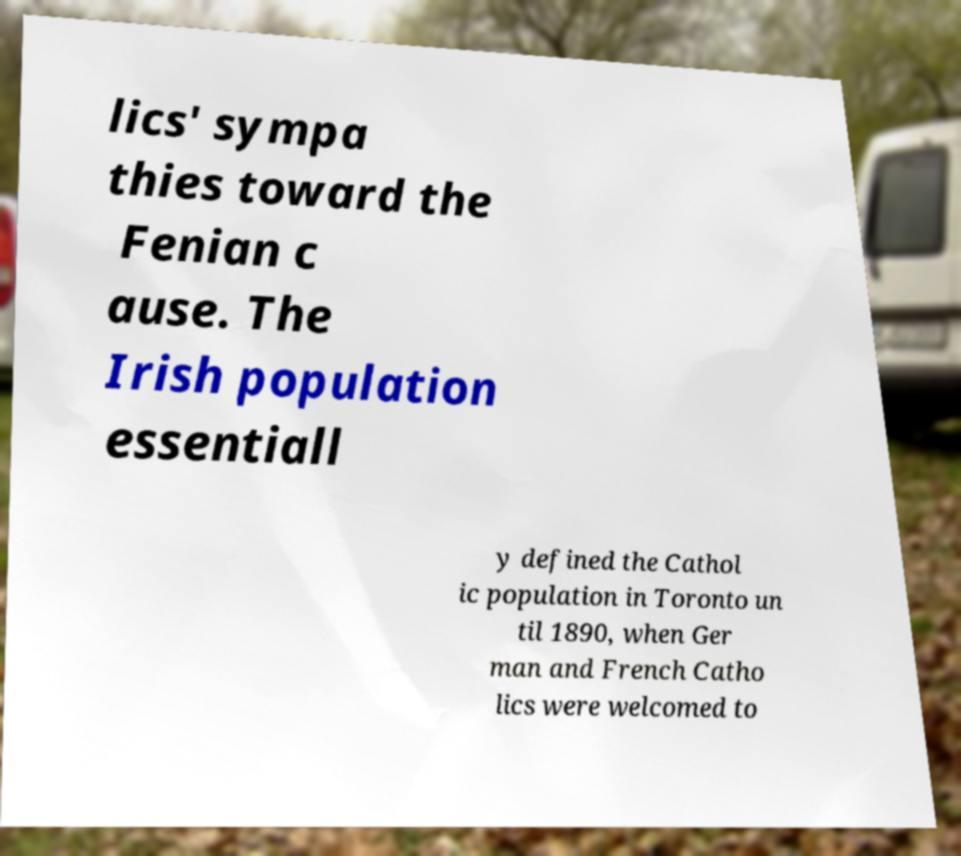There's text embedded in this image that I need extracted. Can you transcribe it verbatim? lics' sympa thies toward the Fenian c ause. The Irish population essentiall y defined the Cathol ic population in Toronto un til 1890, when Ger man and French Catho lics were welcomed to 